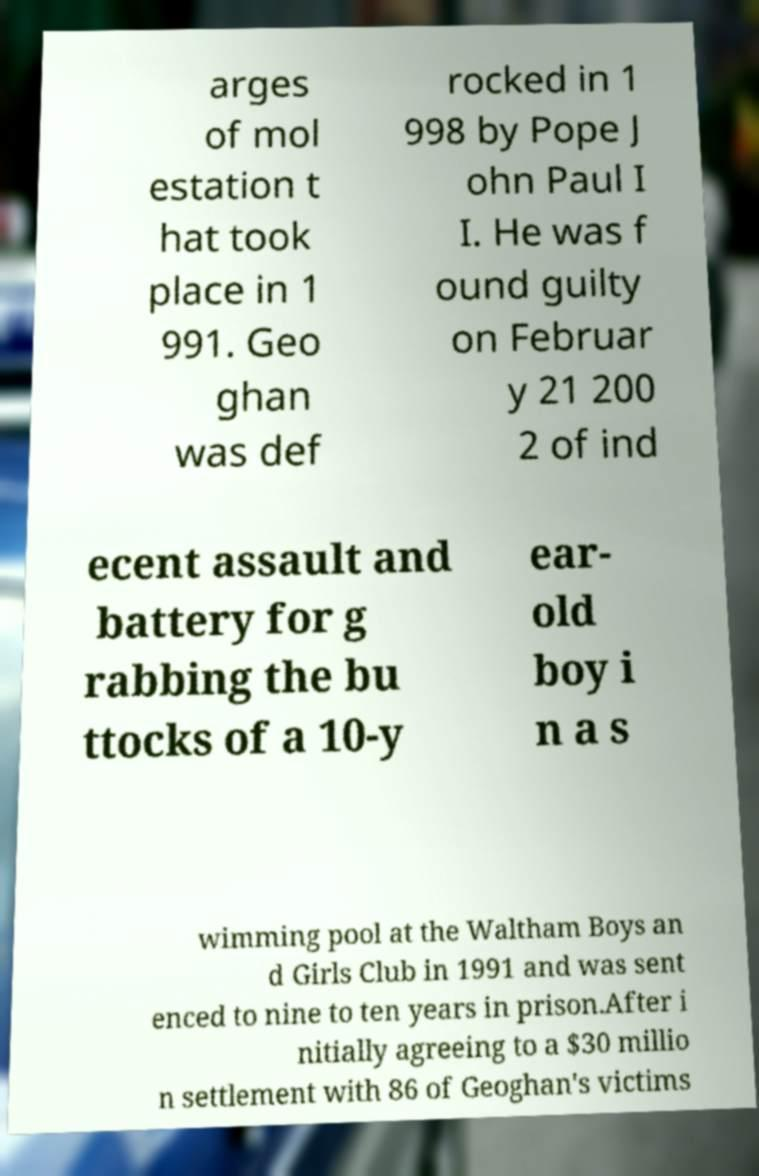Can you read and provide the text displayed in the image?This photo seems to have some interesting text. Can you extract and type it out for me? arges of mol estation t hat took place in 1 991. Geo ghan was def rocked in 1 998 by Pope J ohn Paul I I. He was f ound guilty on Februar y 21 200 2 of ind ecent assault and battery for g rabbing the bu ttocks of a 10-y ear- old boy i n a s wimming pool at the Waltham Boys an d Girls Club in 1991 and was sent enced to nine to ten years in prison.After i nitially agreeing to a $30 millio n settlement with 86 of Geoghan's victims 